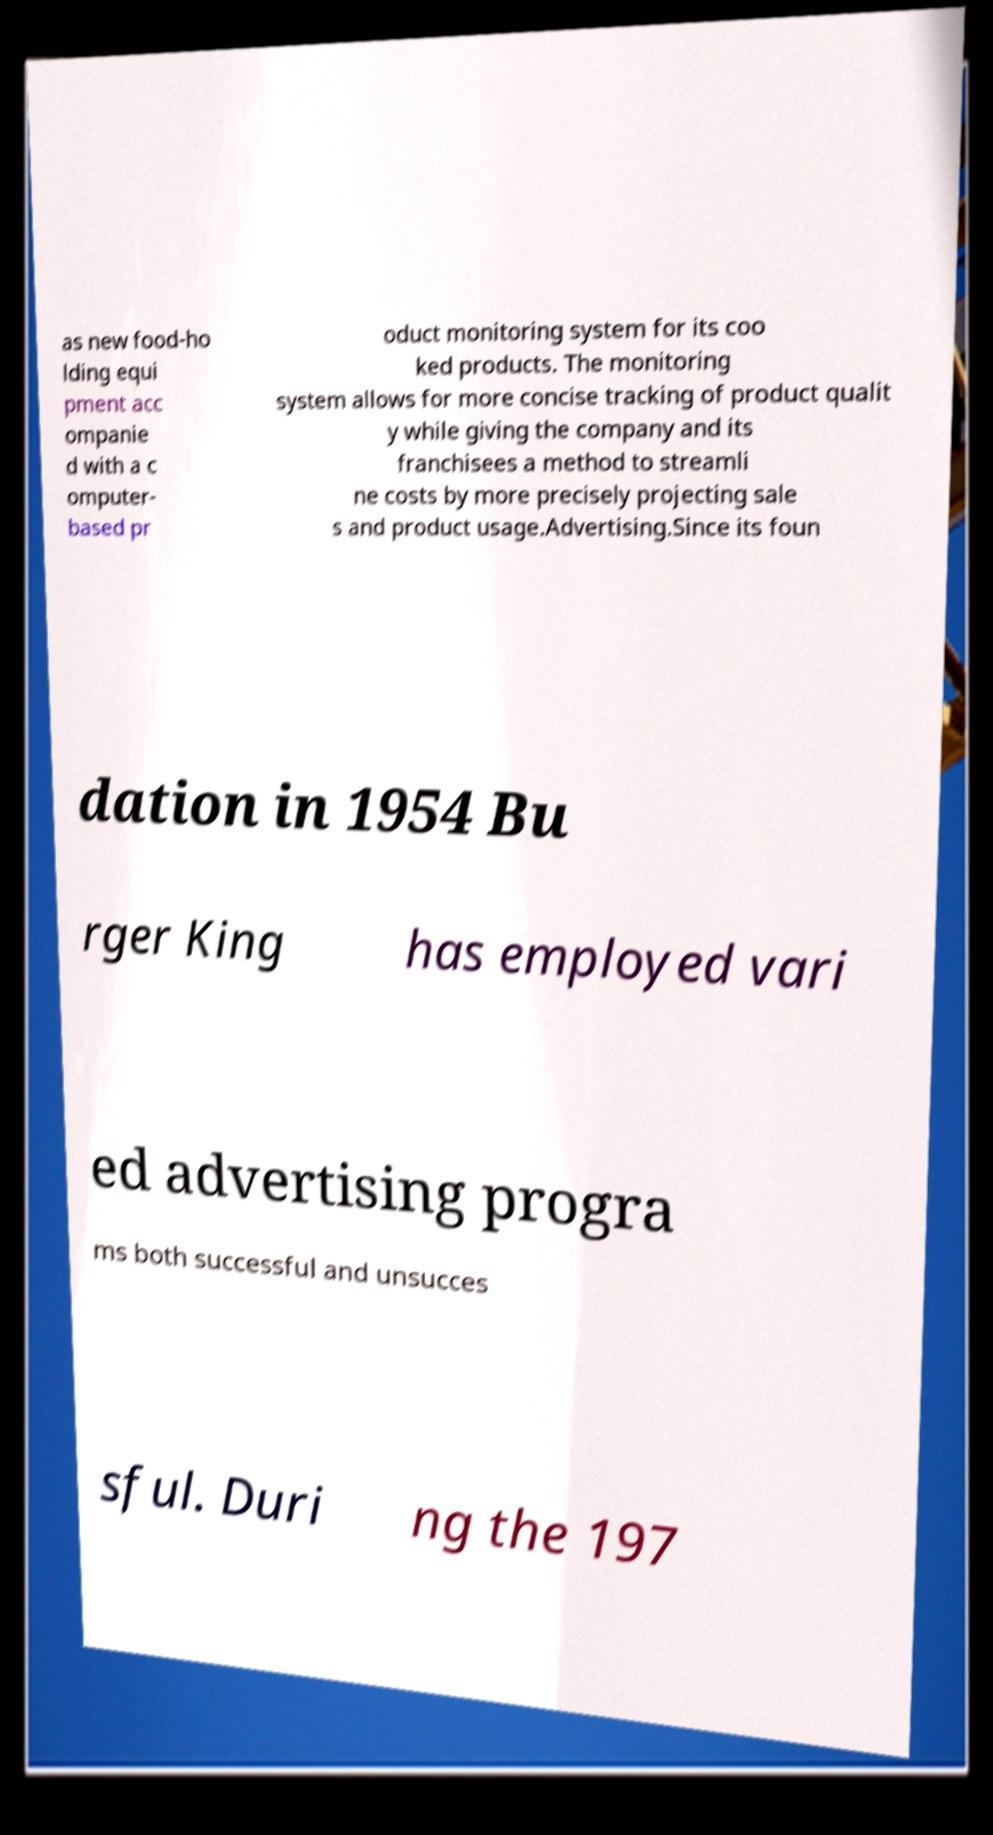Can you accurately transcribe the text from the provided image for me? as new food-ho lding equi pment acc ompanie d with a c omputer- based pr oduct monitoring system for its coo ked products. The monitoring system allows for more concise tracking of product qualit y while giving the company and its franchisees a method to streamli ne costs by more precisely projecting sale s and product usage.Advertising.Since its foun dation in 1954 Bu rger King has employed vari ed advertising progra ms both successful and unsucces sful. Duri ng the 197 